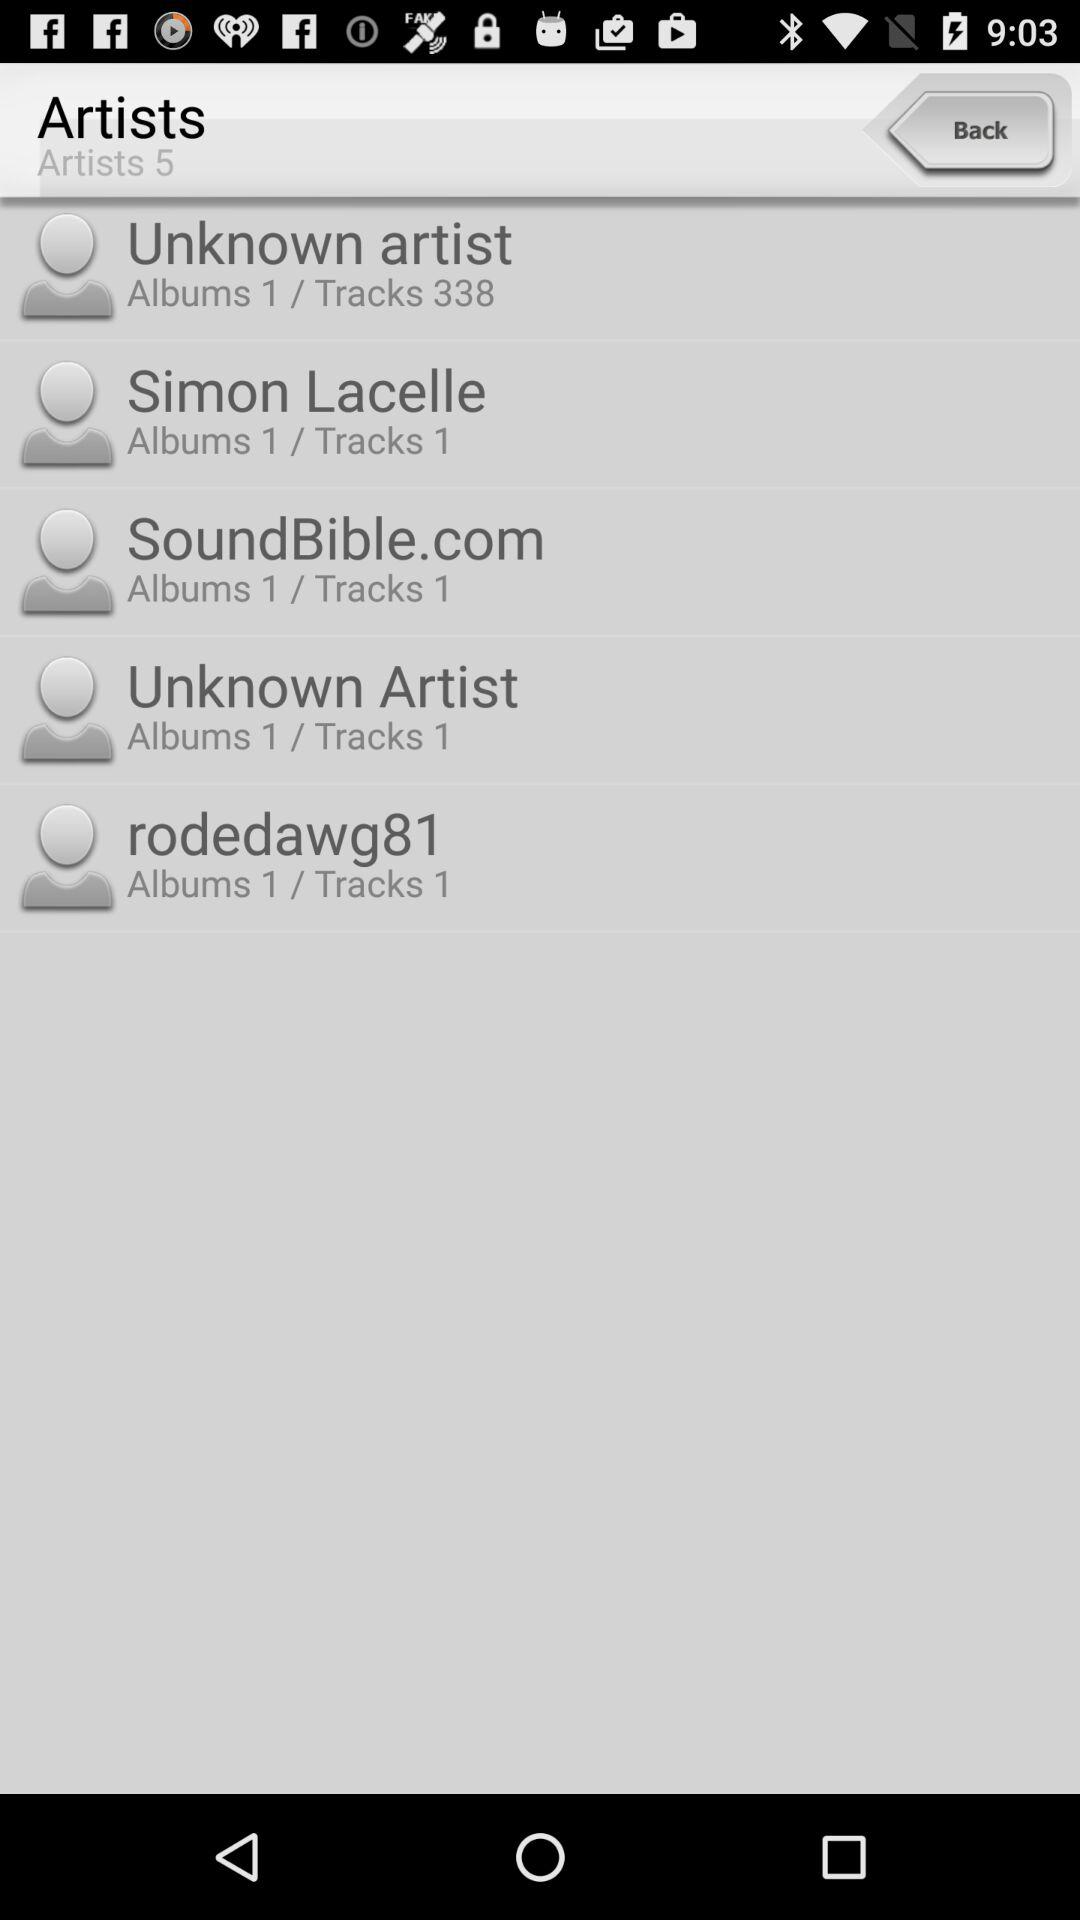What is the number of tracks of "rodedawg81"? The number of tracks of "rodedawg81" is 1. 